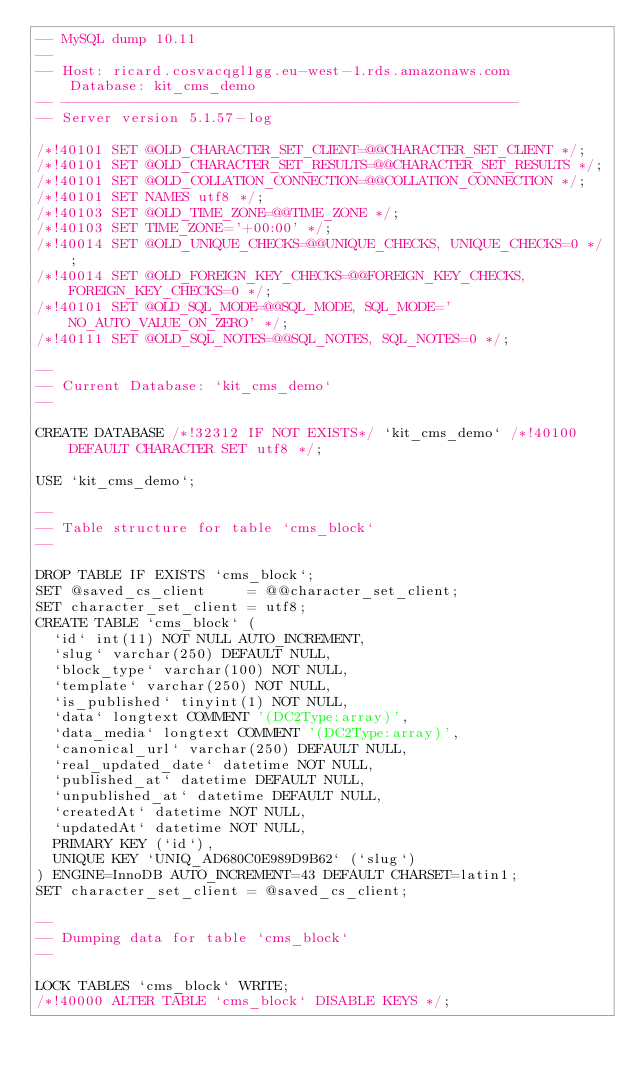<code> <loc_0><loc_0><loc_500><loc_500><_SQL_>-- MySQL dump 10.11
--
-- Host: ricard.cosvacqgl1gg.eu-west-1.rds.amazonaws.com    Database: kit_cms_demo
-- ------------------------------------------------------
-- Server version	5.1.57-log

/*!40101 SET @OLD_CHARACTER_SET_CLIENT=@@CHARACTER_SET_CLIENT */;
/*!40101 SET @OLD_CHARACTER_SET_RESULTS=@@CHARACTER_SET_RESULTS */;
/*!40101 SET @OLD_COLLATION_CONNECTION=@@COLLATION_CONNECTION */;
/*!40101 SET NAMES utf8 */;
/*!40103 SET @OLD_TIME_ZONE=@@TIME_ZONE */;
/*!40103 SET TIME_ZONE='+00:00' */;
/*!40014 SET @OLD_UNIQUE_CHECKS=@@UNIQUE_CHECKS, UNIQUE_CHECKS=0 */;
/*!40014 SET @OLD_FOREIGN_KEY_CHECKS=@@FOREIGN_KEY_CHECKS, FOREIGN_KEY_CHECKS=0 */;
/*!40101 SET @OLD_SQL_MODE=@@SQL_MODE, SQL_MODE='NO_AUTO_VALUE_ON_ZERO' */;
/*!40111 SET @OLD_SQL_NOTES=@@SQL_NOTES, SQL_NOTES=0 */;

--
-- Current Database: `kit_cms_demo`
--

CREATE DATABASE /*!32312 IF NOT EXISTS*/ `kit_cms_demo` /*!40100 DEFAULT CHARACTER SET utf8 */;

USE `kit_cms_demo`;

--
-- Table structure for table `cms_block`
--

DROP TABLE IF EXISTS `cms_block`;
SET @saved_cs_client     = @@character_set_client;
SET character_set_client = utf8;
CREATE TABLE `cms_block` (
  `id` int(11) NOT NULL AUTO_INCREMENT,
  `slug` varchar(250) DEFAULT NULL,
  `block_type` varchar(100) NOT NULL,
  `template` varchar(250) NOT NULL,
  `is_published` tinyint(1) NOT NULL,
  `data` longtext COMMENT '(DC2Type:array)',
  `data_media` longtext COMMENT '(DC2Type:array)',
  `canonical_url` varchar(250) DEFAULT NULL,
  `real_updated_date` datetime NOT NULL,
  `published_at` datetime DEFAULT NULL,
  `unpublished_at` datetime DEFAULT NULL,
  `createdAt` datetime NOT NULL,
  `updatedAt` datetime NOT NULL,
  PRIMARY KEY (`id`),
  UNIQUE KEY `UNIQ_AD680C0E989D9B62` (`slug`)
) ENGINE=InnoDB AUTO_INCREMENT=43 DEFAULT CHARSET=latin1;
SET character_set_client = @saved_cs_client;

--
-- Dumping data for table `cms_block`
--

LOCK TABLES `cms_block` WRITE;
/*!40000 ALTER TABLE `cms_block` DISABLE KEYS */;</code> 